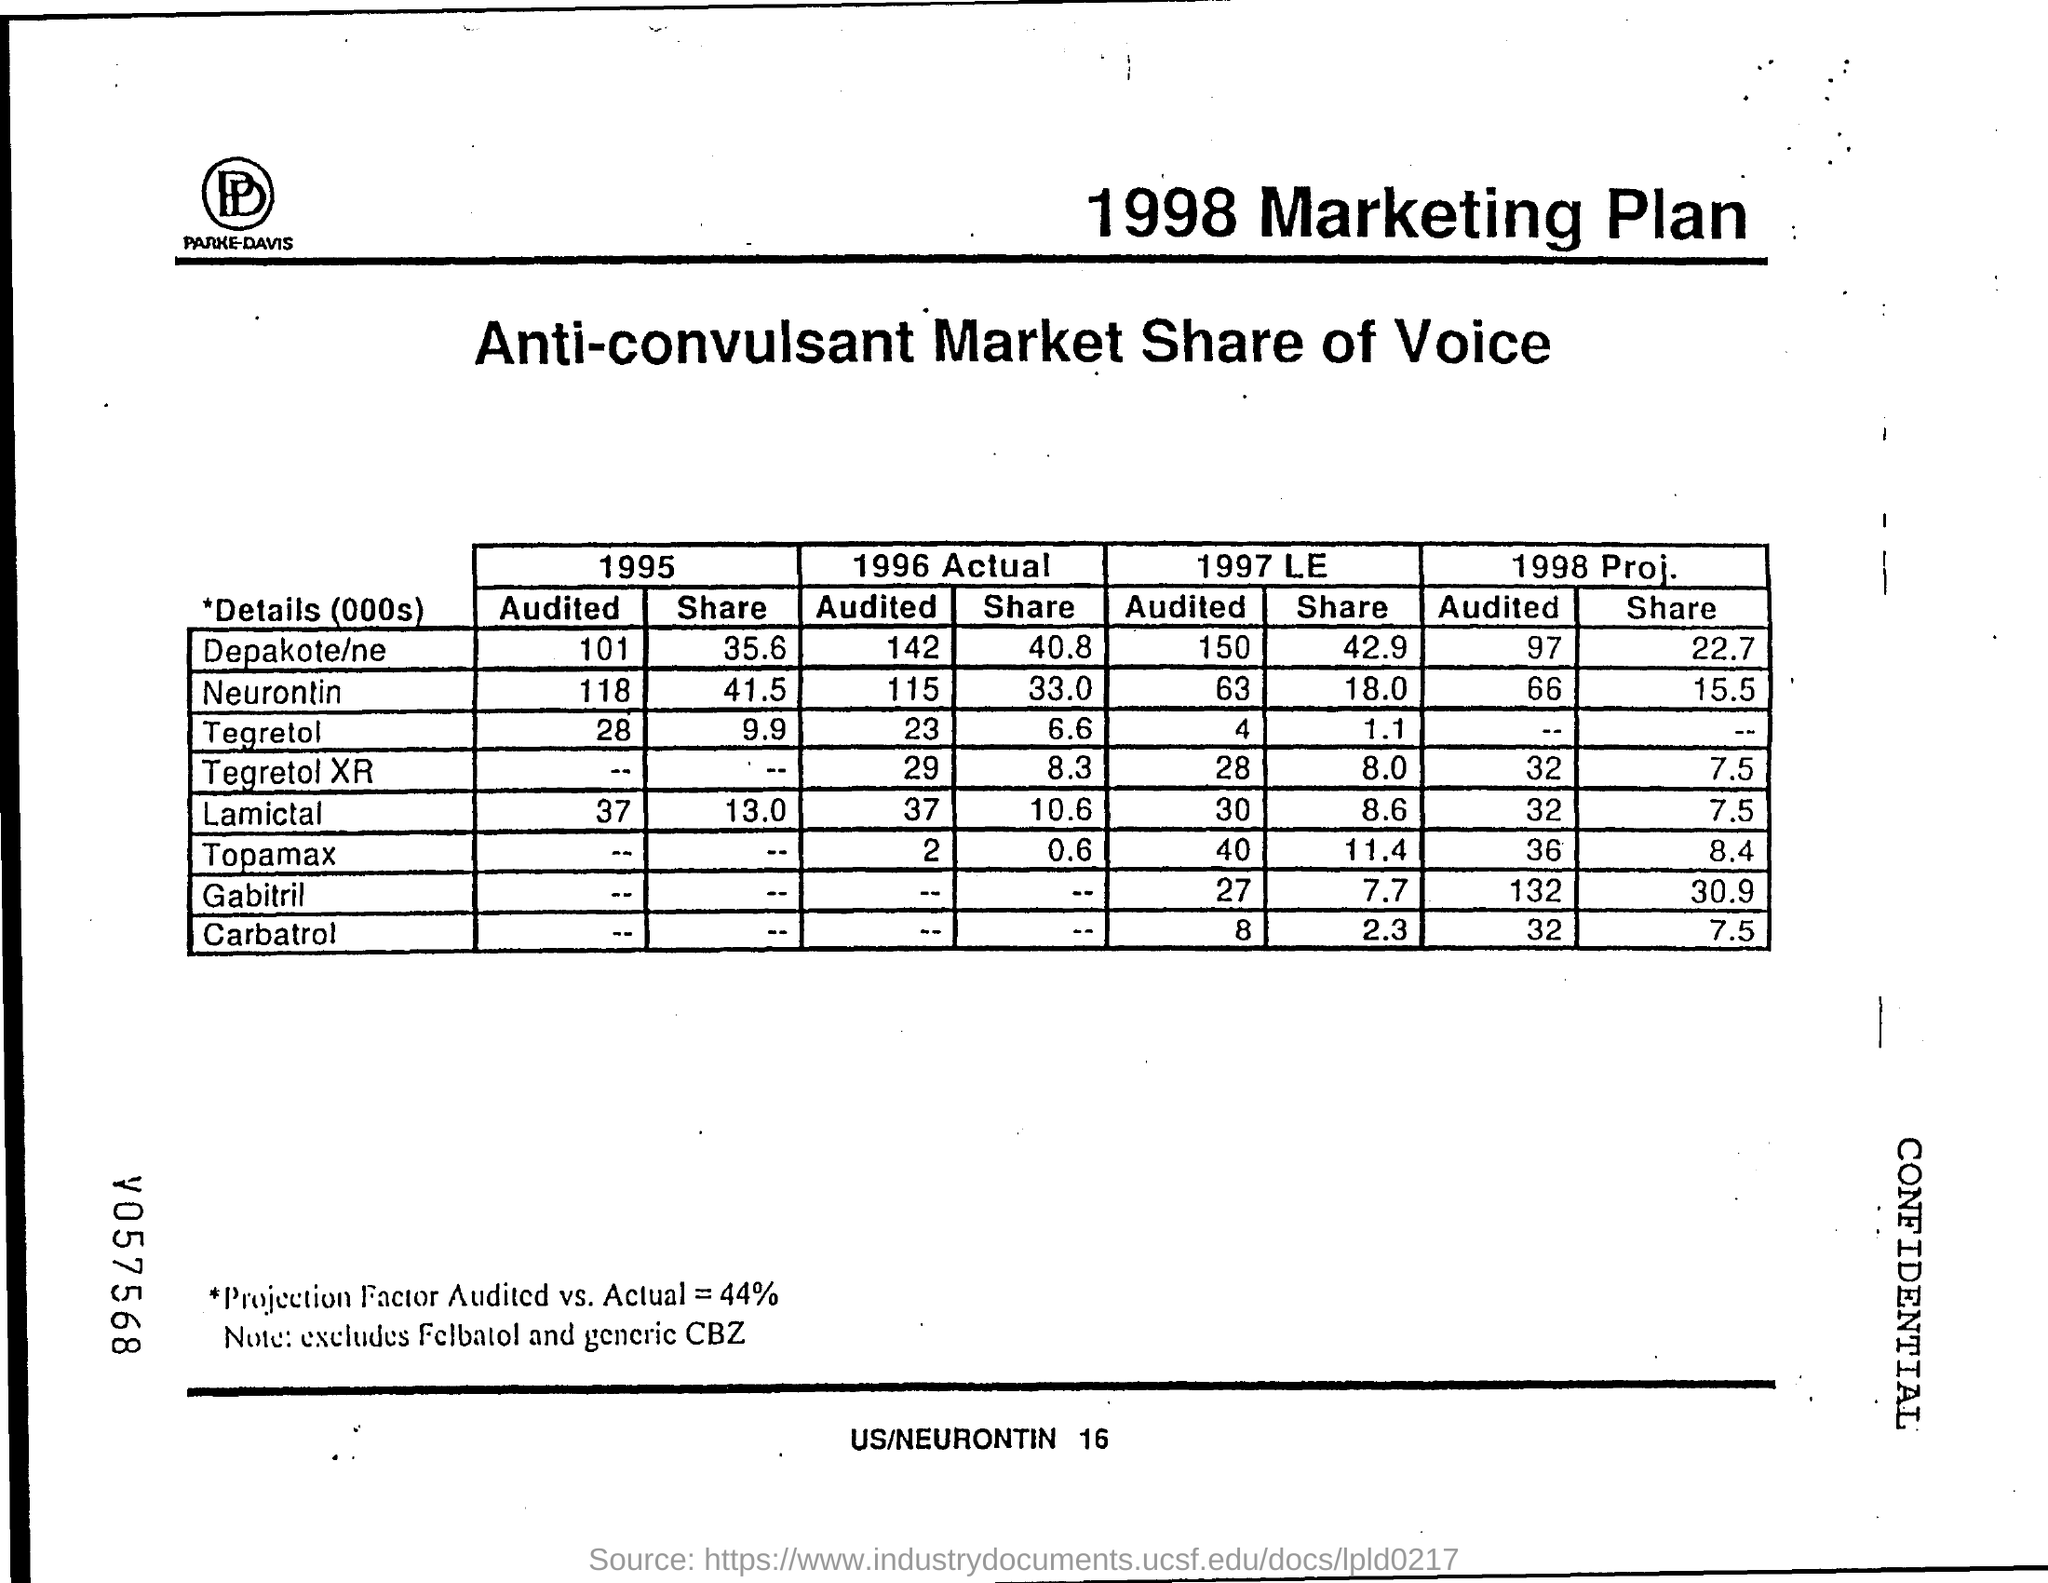Indicate a few pertinent items in this graphic. The value of the "share" for Neurontin in 1995 was 41.5. The value of the Depakote/ne "Share" in 1995 was 35.6%. The Tegretol "share" for the year 1995 was 9.9. The Lamictal "share" value for 1995 was 13.0. What is the Lamictal value for 1995? The audited value for 1995 is 37. 